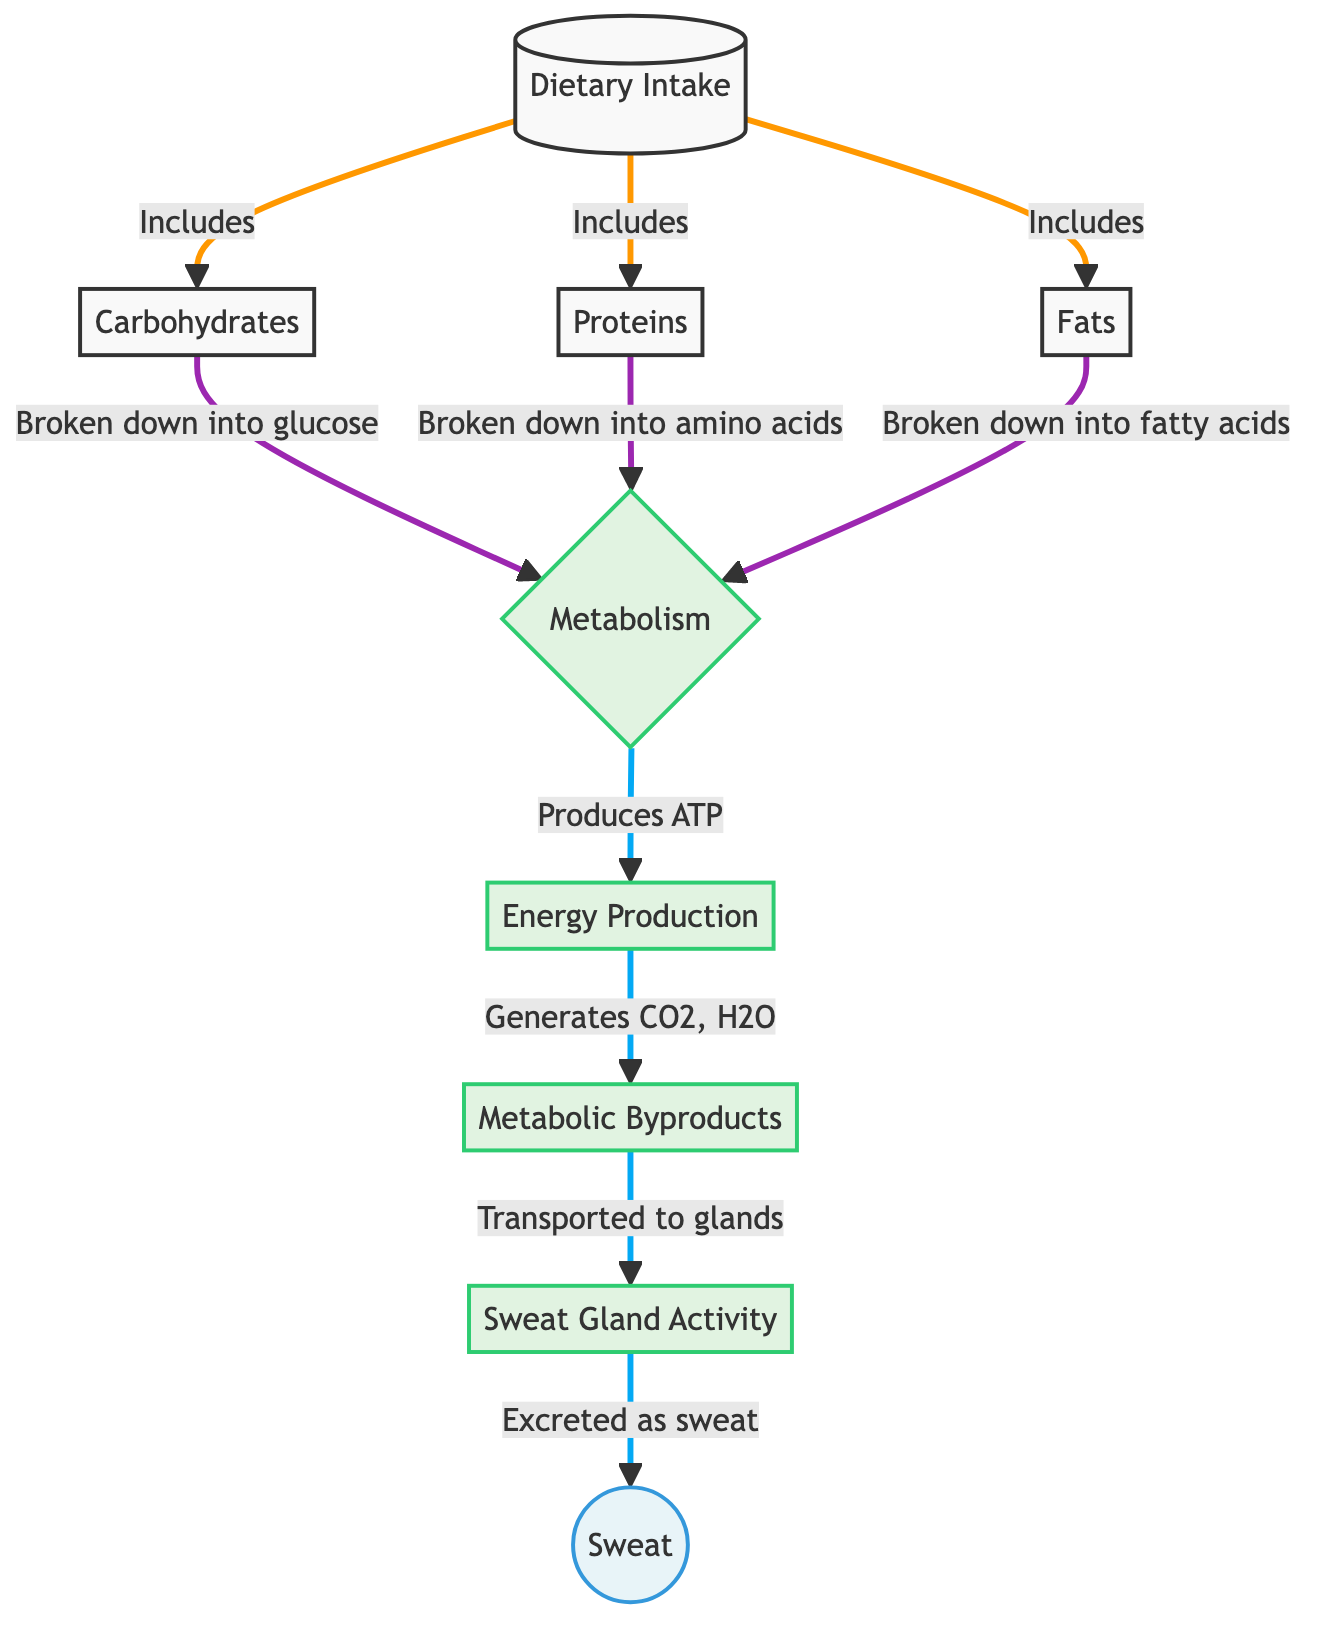what are the three types of macronutrients included in dietary intake? The diagram identifies three macronutrients that contribute to dietary intake: carbohydrates, proteins, and fats. Each of these macronutrients branches off from the "Dietary Intake" node.
Answer: carbohydrates, proteins, fats what is produced from the metabolism of carbohydrates? According to the diagram, carbohydrates are broken down into glucose during metabolism. This information is represented as an output from the carbohydrates node leading into the metabolism node.
Answer: glucose how many metabolic byproducts are generated in sweat production? The diagram shows that metabolism generates two primary byproducts: carbon dioxide and water. This is inferred from the "Metabolic Byproducts" node, which includes these two components.
Answer: 2 which node represents the activity of sweat glands? The diagram indicates that "Sweat Gland Activity" is a process node linked after the metabolic byproducts are transported to the glands. This can be traced through the connections leading from "Metabolic Byproducts" to "Sweat Gland Activity."
Answer: Sweat Gland Activity what are the final products excreted as sweat? The last node in the diagram identifies "Sweat" as the product excreted, which flows from "Sweat Gland Activity." This is the end-point of the metabolic process in sweat production.
Answer: Sweat how do metabolic byproducts reach the sweat glands? The diagram illustrates that metabolic byproducts, such as carbon dioxide and water, are transported to the sweat glands after metabolism, as shown by the arrow leading from "Metabolic Byproducts" to "Sweat Gland Activity."
Answer: Transported to glands what is the ultimate goal of carbohydrate metabolism as depicted in this diagram? The diagram reveals that the primary goal of carbohydrate metabolism is to produce ATP, shown as a direct output from the "Metabolism" node. This indicates energy production as a key outcome.
Answer: Produces ATP how do fats break down in the metabolism process? According to the diagram, fats are broken down into fatty acids during metabolism, as shown by the direct connection from the "Fats" node to the "Metabolism" node detailing this process.
Answer: Fatty acids 